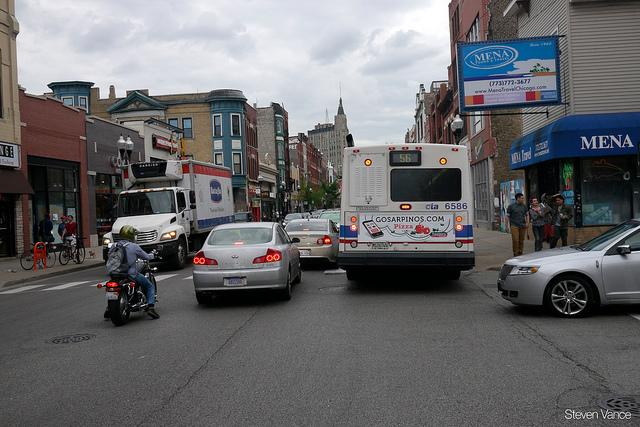Which vehicle stuck in the intersection is in the most danger? motorcycle 